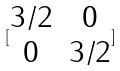Convert formula to latex. <formula><loc_0><loc_0><loc_500><loc_500>[ \begin{matrix} 3 / 2 & 0 \\ 0 & 3 / 2 \end{matrix} ]</formula> 